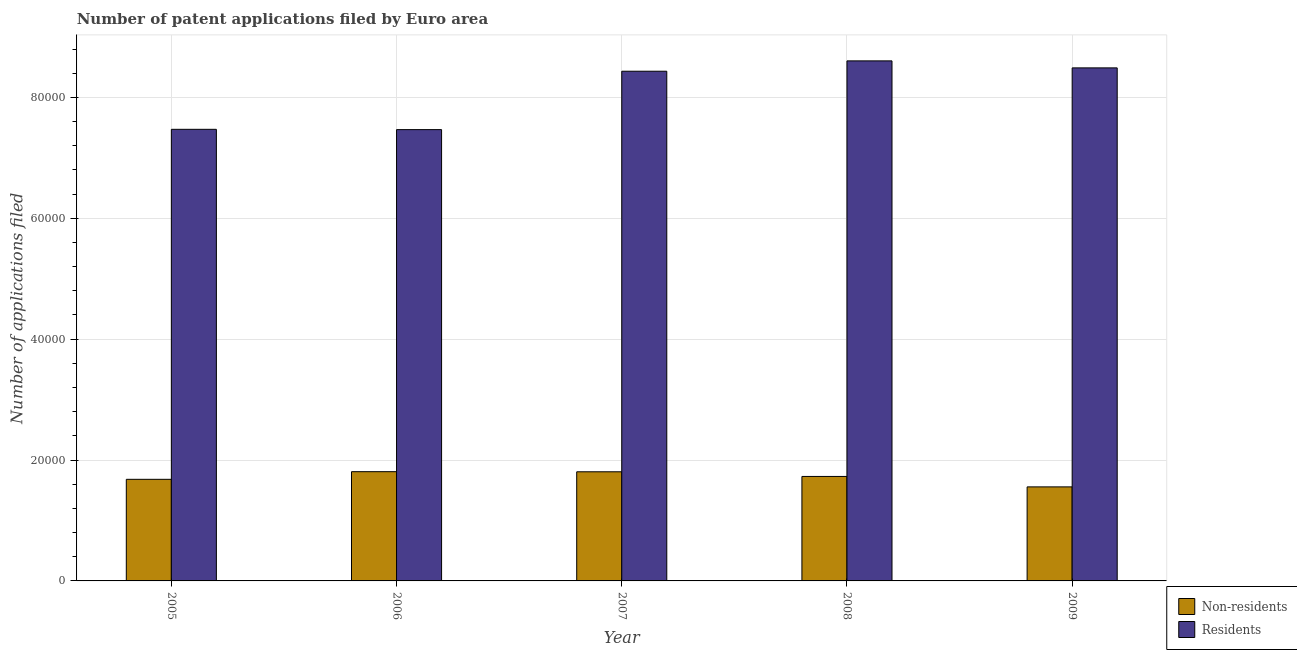How many different coloured bars are there?
Make the answer very short. 2. How many groups of bars are there?
Provide a succinct answer. 5. Are the number of bars on each tick of the X-axis equal?
Give a very brief answer. Yes. How many bars are there on the 2nd tick from the left?
Keep it short and to the point. 2. How many bars are there on the 3rd tick from the right?
Your response must be concise. 2. What is the number of patent applications by non residents in 2006?
Give a very brief answer. 1.81e+04. Across all years, what is the maximum number of patent applications by residents?
Your answer should be compact. 8.60e+04. Across all years, what is the minimum number of patent applications by non residents?
Ensure brevity in your answer.  1.56e+04. In which year was the number of patent applications by residents maximum?
Give a very brief answer. 2008. In which year was the number of patent applications by residents minimum?
Your response must be concise. 2006. What is the total number of patent applications by non residents in the graph?
Keep it short and to the point. 8.58e+04. What is the difference between the number of patent applications by residents in 2006 and that in 2007?
Your response must be concise. -9662. What is the difference between the number of patent applications by residents in 2006 and the number of patent applications by non residents in 2007?
Your answer should be very brief. -9662. What is the average number of patent applications by non residents per year?
Your answer should be very brief. 1.72e+04. What is the ratio of the number of patent applications by residents in 2006 to that in 2007?
Offer a terse response. 0.89. Is the number of patent applications by non residents in 2005 less than that in 2008?
Provide a succinct answer. Yes. What is the difference between the highest and the lowest number of patent applications by residents?
Ensure brevity in your answer.  1.14e+04. Is the sum of the number of patent applications by non residents in 2005 and 2007 greater than the maximum number of patent applications by residents across all years?
Ensure brevity in your answer.  Yes. What does the 1st bar from the left in 2005 represents?
Make the answer very short. Non-residents. What does the 1st bar from the right in 2007 represents?
Provide a succinct answer. Residents. How many years are there in the graph?
Make the answer very short. 5. What is the difference between two consecutive major ticks on the Y-axis?
Keep it short and to the point. 2.00e+04. Does the graph contain grids?
Your answer should be very brief. Yes. Where does the legend appear in the graph?
Offer a very short reply. Bottom right. How many legend labels are there?
Ensure brevity in your answer.  2. How are the legend labels stacked?
Your answer should be very brief. Vertical. What is the title of the graph?
Ensure brevity in your answer.  Number of patent applications filed by Euro area. What is the label or title of the X-axis?
Offer a terse response. Year. What is the label or title of the Y-axis?
Give a very brief answer. Number of applications filed. What is the Number of applications filed of Non-residents in 2005?
Provide a succinct answer. 1.68e+04. What is the Number of applications filed in Residents in 2005?
Keep it short and to the point. 7.47e+04. What is the Number of applications filed of Non-residents in 2006?
Give a very brief answer. 1.81e+04. What is the Number of applications filed in Residents in 2006?
Make the answer very short. 7.47e+04. What is the Number of applications filed of Non-residents in 2007?
Provide a succinct answer. 1.81e+04. What is the Number of applications filed in Residents in 2007?
Offer a terse response. 8.43e+04. What is the Number of applications filed in Non-residents in 2008?
Make the answer very short. 1.73e+04. What is the Number of applications filed in Residents in 2008?
Keep it short and to the point. 8.60e+04. What is the Number of applications filed in Non-residents in 2009?
Your response must be concise. 1.56e+04. What is the Number of applications filed of Residents in 2009?
Your answer should be compact. 8.49e+04. Across all years, what is the maximum Number of applications filed of Non-residents?
Give a very brief answer. 1.81e+04. Across all years, what is the maximum Number of applications filed in Residents?
Your response must be concise. 8.60e+04. Across all years, what is the minimum Number of applications filed in Non-residents?
Offer a very short reply. 1.56e+04. Across all years, what is the minimum Number of applications filed in Residents?
Make the answer very short. 7.47e+04. What is the total Number of applications filed in Non-residents in the graph?
Your answer should be very brief. 8.58e+04. What is the total Number of applications filed of Residents in the graph?
Your answer should be very brief. 4.05e+05. What is the difference between the Number of applications filed of Non-residents in 2005 and that in 2006?
Offer a terse response. -1263. What is the difference between the Number of applications filed in Non-residents in 2005 and that in 2007?
Your answer should be very brief. -1245. What is the difference between the Number of applications filed of Residents in 2005 and that in 2007?
Provide a succinct answer. -9611. What is the difference between the Number of applications filed in Non-residents in 2005 and that in 2008?
Keep it short and to the point. -475. What is the difference between the Number of applications filed in Residents in 2005 and that in 2008?
Your answer should be compact. -1.13e+04. What is the difference between the Number of applications filed of Non-residents in 2005 and that in 2009?
Your response must be concise. 1252. What is the difference between the Number of applications filed of Residents in 2005 and that in 2009?
Keep it short and to the point. -1.02e+04. What is the difference between the Number of applications filed of Non-residents in 2006 and that in 2007?
Your response must be concise. 18. What is the difference between the Number of applications filed in Residents in 2006 and that in 2007?
Offer a terse response. -9662. What is the difference between the Number of applications filed of Non-residents in 2006 and that in 2008?
Keep it short and to the point. 788. What is the difference between the Number of applications filed in Residents in 2006 and that in 2008?
Make the answer very short. -1.14e+04. What is the difference between the Number of applications filed of Non-residents in 2006 and that in 2009?
Offer a terse response. 2515. What is the difference between the Number of applications filed of Residents in 2006 and that in 2009?
Ensure brevity in your answer.  -1.02e+04. What is the difference between the Number of applications filed in Non-residents in 2007 and that in 2008?
Make the answer very short. 770. What is the difference between the Number of applications filed in Residents in 2007 and that in 2008?
Provide a short and direct response. -1713. What is the difference between the Number of applications filed of Non-residents in 2007 and that in 2009?
Ensure brevity in your answer.  2497. What is the difference between the Number of applications filed in Residents in 2007 and that in 2009?
Ensure brevity in your answer.  -555. What is the difference between the Number of applications filed of Non-residents in 2008 and that in 2009?
Make the answer very short. 1727. What is the difference between the Number of applications filed in Residents in 2008 and that in 2009?
Your answer should be very brief. 1158. What is the difference between the Number of applications filed in Non-residents in 2005 and the Number of applications filed in Residents in 2006?
Provide a short and direct response. -5.79e+04. What is the difference between the Number of applications filed of Non-residents in 2005 and the Number of applications filed of Residents in 2007?
Offer a terse response. -6.75e+04. What is the difference between the Number of applications filed of Non-residents in 2005 and the Number of applications filed of Residents in 2008?
Make the answer very short. -6.92e+04. What is the difference between the Number of applications filed in Non-residents in 2005 and the Number of applications filed in Residents in 2009?
Make the answer very short. -6.81e+04. What is the difference between the Number of applications filed of Non-residents in 2006 and the Number of applications filed of Residents in 2007?
Offer a terse response. -6.63e+04. What is the difference between the Number of applications filed of Non-residents in 2006 and the Number of applications filed of Residents in 2008?
Provide a short and direct response. -6.80e+04. What is the difference between the Number of applications filed of Non-residents in 2006 and the Number of applications filed of Residents in 2009?
Provide a short and direct response. -6.68e+04. What is the difference between the Number of applications filed in Non-residents in 2007 and the Number of applications filed in Residents in 2008?
Keep it short and to the point. -6.80e+04. What is the difference between the Number of applications filed of Non-residents in 2007 and the Number of applications filed of Residents in 2009?
Offer a very short reply. -6.68e+04. What is the difference between the Number of applications filed of Non-residents in 2008 and the Number of applications filed of Residents in 2009?
Keep it short and to the point. -6.76e+04. What is the average Number of applications filed of Non-residents per year?
Keep it short and to the point. 1.72e+04. What is the average Number of applications filed in Residents per year?
Provide a succinct answer. 8.09e+04. In the year 2005, what is the difference between the Number of applications filed in Non-residents and Number of applications filed in Residents?
Provide a short and direct response. -5.79e+04. In the year 2006, what is the difference between the Number of applications filed in Non-residents and Number of applications filed in Residents?
Your answer should be compact. -5.66e+04. In the year 2007, what is the difference between the Number of applications filed of Non-residents and Number of applications filed of Residents?
Give a very brief answer. -6.63e+04. In the year 2008, what is the difference between the Number of applications filed in Non-residents and Number of applications filed in Residents?
Provide a succinct answer. -6.88e+04. In the year 2009, what is the difference between the Number of applications filed in Non-residents and Number of applications filed in Residents?
Your answer should be compact. -6.93e+04. What is the ratio of the Number of applications filed in Non-residents in 2005 to that in 2006?
Your answer should be very brief. 0.93. What is the ratio of the Number of applications filed in Residents in 2005 to that in 2006?
Your response must be concise. 1. What is the ratio of the Number of applications filed in Non-residents in 2005 to that in 2007?
Your answer should be very brief. 0.93. What is the ratio of the Number of applications filed in Residents in 2005 to that in 2007?
Give a very brief answer. 0.89. What is the ratio of the Number of applications filed of Non-residents in 2005 to that in 2008?
Ensure brevity in your answer.  0.97. What is the ratio of the Number of applications filed in Residents in 2005 to that in 2008?
Offer a terse response. 0.87. What is the ratio of the Number of applications filed of Non-residents in 2005 to that in 2009?
Make the answer very short. 1.08. What is the ratio of the Number of applications filed in Residents in 2005 to that in 2009?
Provide a short and direct response. 0.88. What is the ratio of the Number of applications filed of Residents in 2006 to that in 2007?
Your answer should be compact. 0.89. What is the ratio of the Number of applications filed in Non-residents in 2006 to that in 2008?
Provide a short and direct response. 1.05. What is the ratio of the Number of applications filed of Residents in 2006 to that in 2008?
Provide a short and direct response. 0.87. What is the ratio of the Number of applications filed of Non-residents in 2006 to that in 2009?
Give a very brief answer. 1.16. What is the ratio of the Number of applications filed in Residents in 2006 to that in 2009?
Provide a short and direct response. 0.88. What is the ratio of the Number of applications filed in Non-residents in 2007 to that in 2008?
Give a very brief answer. 1.04. What is the ratio of the Number of applications filed in Residents in 2007 to that in 2008?
Your response must be concise. 0.98. What is the ratio of the Number of applications filed in Non-residents in 2007 to that in 2009?
Offer a very short reply. 1.16. What is the ratio of the Number of applications filed of Residents in 2007 to that in 2009?
Your answer should be compact. 0.99. What is the ratio of the Number of applications filed in Non-residents in 2008 to that in 2009?
Your response must be concise. 1.11. What is the ratio of the Number of applications filed of Residents in 2008 to that in 2009?
Your answer should be compact. 1.01. What is the difference between the highest and the second highest Number of applications filed in Residents?
Provide a short and direct response. 1158. What is the difference between the highest and the lowest Number of applications filed in Non-residents?
Offer a terse response. 2515. What is the difference between the highest and the lowest Number of applications filed of Residents?
Give a very brief answer. 1.14e+04. 